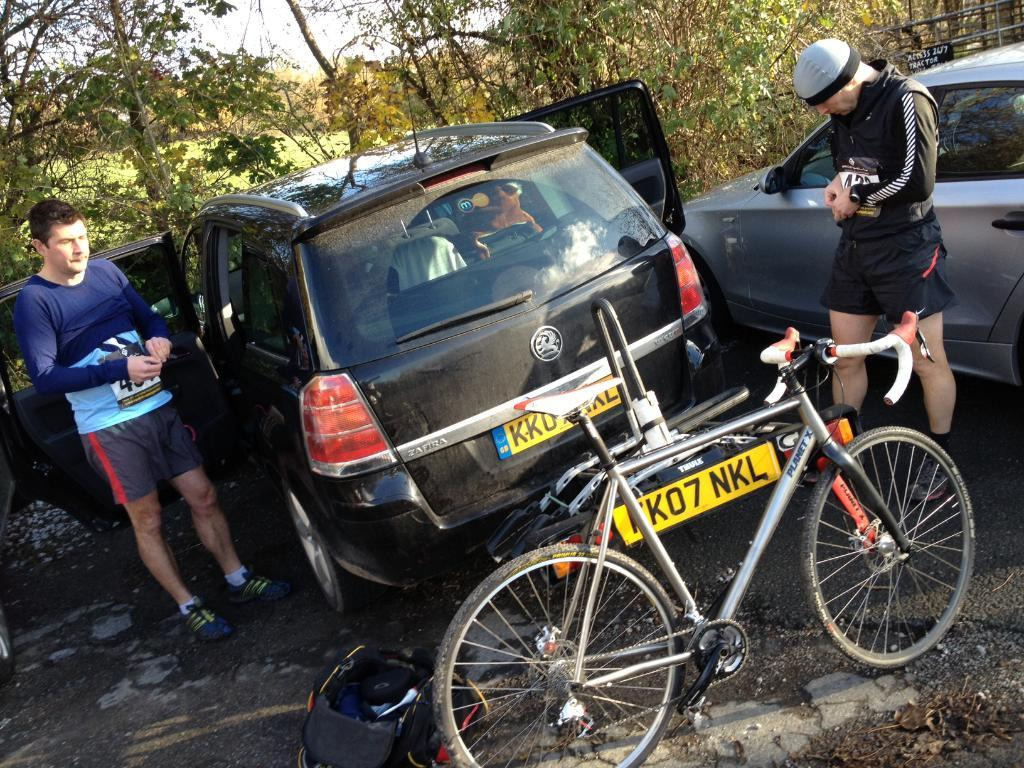How many people are in the image? There are two people in the image. What is one of the people wearing? One of the people is wearing a cap. What type of vehicles are in the image? There are cars in the image. What mode of transportation can also be seen in the image? There is a bicycle in the image. What object is on the road in the image? There is a bag on the road. What can be seen in the background of the image? There are trees in the background of the image. What rule does the aunt enforce in the image? There is no mention of an aunt or any rules in the image. 